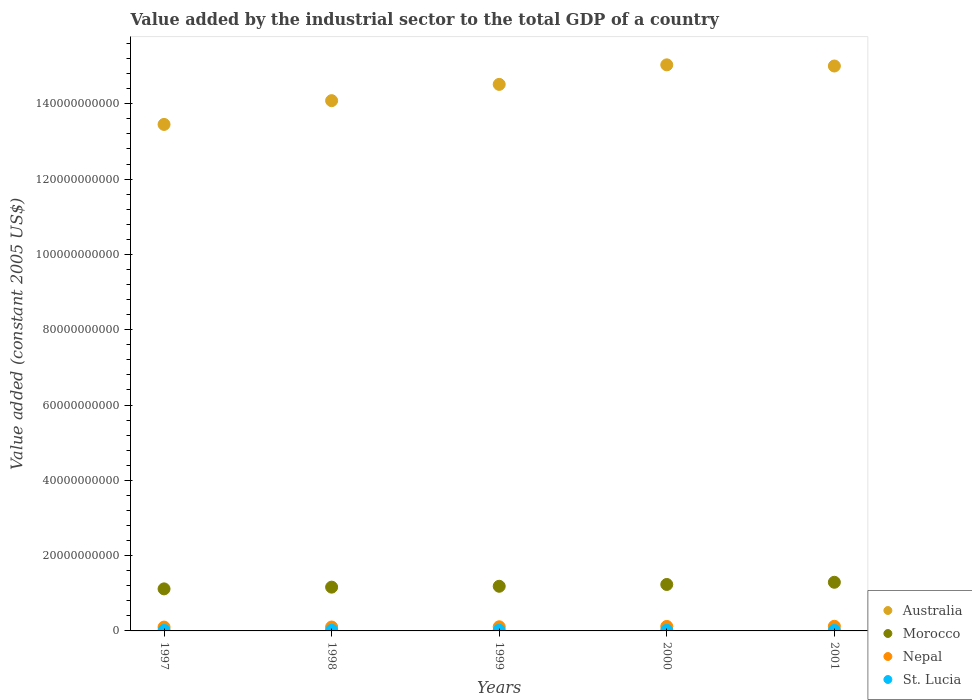How many different coloured dotlines are there?
Your answer should be compact. 4. Is the number of dotlines equal to the number of legend labels?
Your response must be concise. Yes. What is the value added by the industrial sector in St. Lucia in 2000?
Provide a succinct answer. 1.57e+08. Across all years, what is the maximum value added by the industrial sector in Australia?
Your response must be concise. 1.50e+11. Across all years, what is the minimum value added by the industrial sector in Morocco?
Give a very brief answer. 1.12e+1. What is the total value added by the industrial sector in St. Lucia in the graph?
Ensure brevity in your answer.  7.94e+08. What is the difference between the value added by the industrial sector in St. Lucia in 1997 and that in 2001?
Give a very brief answer. 7.04e+06. What is the difference between the value added by the industrial sector in St. Lucia in 1997 and the value added by the industrial sector in Nepal in 2000?
Your answer should be compact. -1.04e+09. What is the average value added by the industrial sector in Morocco per year?
Your answer should be compact. 1.20e+1. In the year 1998, what is the difference between the value added by the industrial sector in Morocco and value added by the industrial sector in Australia?
Offer a terse response. -1.29e+11. In how many years, is the value added by the industrial sector in Morocco greater than 76000000000 US$?
Offer a terse response. 0. What is the ratio of the value added by the industrial sector in Morocco in 2000 to that in 2001?
Offer a terse response. 0.95. What is the difference between the highest and the second highest value added by the industrial sector in Morocco?
Your response must be concise. 5.85e+08. What is the difference between the highest and the lowest value added by the industrial sector in Morocco?
Provide a succinct answer. 1.75e+09. Is the sum of the value added by the industrial sector in Morocco in 1999 and 2000 greater than the maximum value added by the industrial sector in St. Lucia across all years?
Give a very brief answer. Yes. Is it the case that in every year, the sum of the value added by the industrial sector in Australia and value added by the industrial sector in Nepal  is greater than the value added by the industrial sector in Morocco?
Give a very brief answer. Yes. Does the value added by the industrial sector in St. Lucia monotonically increase over the years?
Provide a short and direct response. No. Is the value added by the industrial sector in Nepal strictly greater than the value added by the industrial sector in Australia over the years?
Provide a short and direct response. No. Is the value added by the industrial sector in Morocco strictly less than the value added by the industrial sector in Australia over the years?
Ensure brevity in your answer.  Yes. How many dotlines are there?
Your response must be concise. 4. How many years are there in the graph?
Your response must be concise. 5. Are the values on the major ticks of Y-axis written in scientific E-notation?
Ensure brevity in your answer.  No. Does the graph contain any zero values?
Provide a short and direct response. No. Does the graph contain grids?
Provide a succinct answer. No. How many legend labels are there?
Your answer should be very brief. 4. How are the legend labels stacked?
Offer a very short reply. Vertical. What is the title of the graph?
Offer a terse response. Value added by the industrial sector to the total GDP of a country. Does "Middle income" appear as one of the legend labels in the graph?
Provide a succinct answer. No. What is the label or title of the X-axis?
Your answer should be compact. Years. What is the label or title of the Y-axis?
Offer a very short reply. Value added (constant 2005 US$). What is the Value added (constant 2005 US$) in Australia in 1997?
Provide a succinct answer. 1.35e+11. What is the Value added (constant 2005 US$) of Morocco in 1997?
Provide a short and direct response. 1.12e+1. What is the Value added (constant 2005 US$) of Nepal in 1997?
Give a very brief answer. 1.01e+09. What is the Value added (constant 2005 US$) of St. Lucia in 1997?
Keep it short and to the point. 1.49e+08. What is the Value added (constant 2005 US$) of Australia in 1998?
Your response must be concise. 1.41e+11. What is the Value added (constant 2005 US$) in Morocco in 1998?
Offer a terse response. 1.16e+1. What is the Value added (constant 2005 US$) of Nepal in 1998?
Ensure brevity in your answer.  1.04e+09. What is the Value added (constant 2005 US$) in St. Lucia in 1998?
Offer a very short reply. 1.66e+08. What is the Value added (constant 2005 US$) in Australia in 1999?
Offer a terse response. 1.45e+11. What is the Value added (constant 2005 US$) in Morocco in 1999?
Offer a terse response. 1.19e+1. What is the Value added (constant 2005 US$) in Nepal in 1999?
Your response must be concise. 1.10e+09. What is the Value added (constant 2005 US$) in St. Lucia in 1999?
Keep it short and to the point. 1.80e+08. What is the Value added (constant 2005 US$) of Australia in 2000?
Your answer should be compact. 1.50e+11. What is the Value added (constant 2005 US$) of Morocco in 2000?
Give a very brief answer. 1.23e+1. What is the Value added (constant 2005 US$) of Nepal in 2000?
Make the answer very short. 1.19e+09. What is the Value added (constant 2005 US$) of St. Lucia in 2000?
Your response must be concise. 1.57e+08. What is the Value added (constant 2005 US$) of Australia in 2001?
Your response must be concise. 1.50e+11. What is the Value added (constant 2005 US$) in Morocco in 2001?
Make the answer very short. 1.29e+1. What is the Value added (constant 2005 US$) of Nepal in 2001?
Offer a terse response. 1.23e+09. What is the Value added (constant 2005 US$) in St. Lucia in 2001?
Your answer should be very brief. 1.42e+08. Across all years, what is the maximum Value added (constant 2005 US$) of Australia?
Your answer should be very brief. 1.50e+11. Across all years, what is the maximum Value added (constant 2005 US$) in Morocco?
Offer a very short reply. 1.29e+1. Across all years, what is the maximum Value added (constant 2005 US$) of Nepal?
Your answer should be very brief. 1.23e+09. Across all years, what is the maximum Value added (constant 2005 US$) in St. Lucia?
Ensure brevity in your answer.  1.80e+08. Across all years, what is the minimum Value added (constant 2005 US$) of Australia?
Make the answer very short. 1.35e+11. Across all years, what is the minimum Value added (constant 2005 US$) in Morocco?
Offer a terse response. 1.12e+1. Across all years, what is the minimum Value added (constant 2005 US$) in Nepal?
Offer a very short reply. 1.01e+09. Across all years, what is the minimum Value added (constant 2005 US$) of St. Lucia?
Offer a terse response. 1.42e+08. What is the total Value added (constant 2005 US$) of Australia in the graph?
Offer a terse response. 7.21e+11. What is the total Value added (constant 2005 US$) of Morocco in the graph?
Give a very brief answer. 5.99e+1. What is the total Value added (constant 2005 US$) of Nepal in the graph?
Your answer should be compact. 5.57e+09. What is the total Value added (constant 2005 US$) in St. Lucia in the graph?
Give a very brief answer. 7.94e+08. What is the difference between the Value added (constant 2005 US$) in Australia in 1997 and that in 1998?
Ensure brevity in your answer.  -6.31e+09. What is the difference between the Value added (constant 2005 US$) in Morocco in 1997 and that in 1998?
Offer a very short reply. -4.59e+08. What is the difference between the Value added (constant 2005 US$) in Nepal in 1997 and that in 1998?
Your answer should be very brief. -2.34e+07. What is the difference between the Value added (constant 2005 US$) in St. Lucia in 1997 and that in 1998?
Give a very brief answer. -1.72e+07. What is the difference between the Value added (constant 2005 US$) of Australia in 1997 and that in 1999?
Ensure brevity in your answer.  -1.06e+1. What is the difference between the Value added (constant 2005 US$) in Morocco in 1997 and that in 1999?
Give a very brief answer. -6.90e+08. What is the difference between the Value added (constant 2005 US$) of Nepal in 1997 and that in 1999?
Provide a succinct answer. -8.55e+07. What is the difference between the Value added (constant 2005 US$) in St. Lucia in 1997 and that in 1999?
Give a very brief answer. -3.13e+07. What is the difference between the Value added (constant 2005 US$) of Australia in 1997 and that in 2000?
Your answer should be very brief. -1.58e+1. What is the difference between the Value added (constant 2005 US$) of Morocco in 1997 and that in 2000?
Keep it short and to the point. -1.17e+09. What is the difference between the Value added (constant 2005 US$) of Nepal in 1997 and that in 2000?
Make the answer very short. -1.76e+08. What is the difference between the Value added (constant 2005 US$) in St. Lucia in 1997 and that in 2000?
Offer a terse response. -8.48e+06. What is the difference between the Value added (constant 2005 US$) of Australia in 1997 and that in 2001?
Make the answer very short. -1.55e+1. What is the difference between the Value added (constant 2005 US$) of Morocco in 1997 and that in 2001?
Ensure brevity in your answer.  -1.75e+09. What is the difference between the Value added (constant 2005 US$) in Nepal in 1997 and that in 2001?
Your answer should be very brief. -2.19e+08. What is the difference between the Value added (constant 2005 US$) of St. Lucia in 1997 and that in 2001?
Provide a succinct answer. 7.04e+06. What is the difference between the Value added (constant 2005 US$) of Australia in 1998 and that in 1999?
Offer a very short reply. -4.32e+09. What is the difference between the Value added (constant 2005 US$) in Morocco in 1998 and that in 1999?
Ensure brevity in your answer.  -2.32e+08. What is the difference between the Value added (constant 2005 US$) in Nepal in 1998 and that in 1999?
Provide a succinct answer. -6.21e+07. What is the difference between the Value added (constant 2005 US$) in St. Lucia in 1998 and that in 1999?
Your answer should be very brief. -1.40e+07. What is the difference between the Value added (constant 2005 US$) in Australia in 1998 and that in 2000?
Give a very brief answer. -9.51e+09. What is the difference between the Value added (constant 2005 US$) of Morocco in 1998 and that in 2000?
Ensure brevity in your answer.  -7.09e+08. What is the difference between the Value added (constant 2005 US$) of Nepal in 1998 and that in 2000?
Your answer should be very brief. -1.52e+08. What is the difference between the Value added (constant 2005 US$) of St. Lucia in 1998 and that in 2000?
Offer a terse response. 8.74e+06. What is the difference between the Value added (constant 2005 US$) in Australia in 1998 and that in 2001?
Make the answer very short. -9.20e+09. What is the difference between the Value added (constant 2005 US$) in Morocco in 1998 and that in 2001?
Keep it short and to the point. -1.29e+09. What is the difference between the Value added (constant 2005 US$) of Nepal in 1998 and that in 2001?
Provide a succinct answer. -1.95e+08. What is the difference between the Value added (constant 2005 US$) in St. Lucia in 1998 and that in 2001?
Offer a very short reply. 2.43e+07. What is the difference between the Value added (constant 2005 US$) in Australia in 1999 and that in 2000?
Provide a short and direct response. -5.19e+09. What is the difference between the Value added (constant 2005 US$) in Morocco in 1999 and that in 2000?
Offer a terse response. -4.78e+08. What is the difference between the Value added (constant 2005 US$) in Nepal in 1999 and that in 2000?
Your answer should be compact. -9.02e+07. What is the difference between the Value added (constant 2005 US$) of St. Lucia in 1999 and that in 2000?
Give a very brief answer. 2.28e+07. What is the difference between the Value added (constant 2005 US$) in Australia in 1999 and that in 2001?
Keep it short and to the point. -4.88e+09. What is the difference between the Value added (constant 2005 US$) of Morocco in 1999 and that in 2001?
Your response must be concise. -1.06e+09. What is the difference between the Value added (constant 2005 US$) of Nepal in 1999 and that in 2001?
Provide a short and direct response. -1.33e+08. What is the difference between the Value added (constant 2005 US$) in St. Lucia in 1999 and that in 2001?
Ensure brevity in your answer.  3.83e+07. What is the difference between the Value added (constant 2005 US$) of Australia in 2000 and that in 2001?
Offer a very short reply. 3.08e+08. What is the difference between the Value added (constant 2005 US$) in Morocco in 2000 and that in 2001?
Give a very brief answer. -5.85e+08. What is the difference between the Value added (constant 2005 US$) of Nepal in 2000 and that in 2001?
Keep it short and to the point. -4.28e+07. What is the difference between the Value added (constant 2005 US$) in St. Lucia in 2000 and that in 2001?
Offer a very short reply. 1.55e+07. What is the difference between the Value added (constant 2005 US$) in Australia in 1997 and the Value added (constant 2005 US$) in Morocco in 1998?
Keep it short and to the point. 1.23e+11. What is the difference between the Value added (constant 2005 US$) in Australia in 1997 and the Value added (constant 2005 US$) in Nepal in 1998?
Provide a succinct answer. 1.33e+11. What is the difference between the Value added (constant 2005 US$) in Australia in 1997 and the Value added (constant 2005 US$) in St. Lucia in 1998?
Provide a short and direct response. 1.34e+11. What is the difference between the Value added (constant 2005 US$) of Morocco in 1997 and the Value added (constant 2005 US$) of Nepal in 1998?
Keep it short and to the point. 1.01e+1. What is the difference between the Value added (constant 2005 US$) in Morocco in 1997 and the Value added (constant 2005 US$) in St. Lucia in 1998?
Make the answer very short. 1.10e+1. What is the difference between the Value added (constant 2005 US$) of Nepal in 1997 and the Value added (constant 2005 US$) of St. Lucia in 1998?
Your response must be concise. 8.48e+08. What is the difference between the Value added (constant 2005 US$) in Australia in 1997 and the Value added (constant 2005 US$) in Morocco in 1999?
Make the answer very short. 1.23e+11. What is the difference between the Value added (constant 2005 US$) in Australia in 1997 and the Value added (constant 2005 US$) in Nepal in 1999?
Your response must be concise. 1.33e+11. What is the difference between the Value added (constant 2005 US$) of Australia in 1997 and the Value added (constant 2005 US$) of St. Lucia in 1999?
Your answer should be very brief. 1.34e+11. What is the difference between the Value added (constant 2005 US$) of Morocco in 1997 and the Value added (constant 2005 US$) of Nepal in 1999?
Ensure brevity in your answer.  1.01e+1. What is the difference between the Value added (constant 2005 US$) in Morocco in 1997 and the Value added (constant 2005 US$) in St. Lucia in 1999?
Give a very brief answer. 1.10e+1. What is the difference between the Value added (constant 2005 US$) in Nepal in 1997 and the Value added (constant 2005 US$) in St. Lucia in 1999?
Your response must be concise. 8.34e+08. What is the difference between the Value added (constant 2005 US$) in Australia in 1997 and the Value added (constant 2005 US$) in Morocco in 2000?
Your answer should be compact. 1.22e+11. What is the difference between the Value added (constant 2005 US$) in Australia in 1997 and the Value added (constant 2005 US$) in Nepal in 2000?
Your response must be concise. 1.33e+11. What is the difference between the Value added (constant 2005 US$) in Australia in 1997 and the Value added (constant 2005 US$) in St. Lucia in 2000?
Offer a very short reply. 1.34e+11. What is the difference between the Value added (constant 2005 US$) in Morocco in 1997 and the Value added (constant 2005 US$) in Nepal in 2000?
Your answer should be compact. 9.98e+09. What is the difference between the Value added (constant 2005 US$) of Morocco in 1997 and the Value added (constant 2005 US$) of St. Lucia in 2000?
Keep it short and to the point. 1.10e+1. What is the difference between the Value added (constant 2005 US$) of Nepal in 1997 and the Value added (constant 2005 US$) of St. Lucia in 2000?
Your answer should be compact. 8.56e+08. What is the difference between the Value added (constant 2005 US$) of Australia in 1997 and the Value added (constant 2005 US$) of Morocco in 2001?
Your answer should be compact. 1.22e+11. What is the difference between the Value added (constant 2005 US$) in Australia in 1997 and the Value added (constant 2005 US$) in Nepal in 2001?
Provide a succinct answer. 1.33e+11. What is the difference between the Value added (constant 2005 US$) in Australia in 1997 and the Value added (constant 2005 US$) in St. Lucia in 2001?
Make the answer very short. 1.34e+11. What is the difference between the Value added (constant 2005 US$) of Morocco in 1997 and the Value added (constant 2005 US$) of Nepal in 2001?
Give a very brief answer. 9.93e+09. What is the difference between the Value added (constant 2005 US$) in Morocco in 1997 and the Value added (constant 2005 US$) in St. Lucia in 2001?
Your answer should be compact. 1.10e+1. What is the difference between the Value added (constant 2005 US$) of Nepal in 1997 and the Value added (constant 2005 US$) of St. Lucia in 2001?
Make the answer very short. 8.72e+08. What is the difference between the Value added (constant 2005 US$) of Australia in 1998 and the Value added (constant 2005 US$) of Morocco in 1999?
Offer a very short reply. 1.29e+11. What is the difference between the Value added (constant 2005 US$) of Australia in 1998 and the Value added (constant 2005 US$) of Nepal in 1999?
Offer a very short reply. 1.40e+11. What is the difference between the Value added (constant 2005 US$) in Australia in 1998 and the Value added (constant 2005 US$) in St. Lucia in 1999?
Ensure brevity in your answer.  1.41e+11. What is the difference between the Value added (constant 2005 US$) in Morocco in 1998 and the Value added (constant 2005 US$) in Nepal in 1999?
Ensure brevity in your answer.  1.05e+1. What is the difference between the Value added (constant 2005 US$) in Morocco in 1998 and the Value added (constant 2005 US$) in St. Lucia in 1999?
Offer a terse response. 1.14e+1. What is the difference between the Value added (constant 2005 US$) of Nepal in 1998 and the Value added (constant 2005 US$) of St. Lucia in 1999?
Your answer should be very brief. 8.57e+08. What is the difference between the Value added (constant 2005 US$) of Australia in 1998 and the Value added (constant 2005 US$) of Morocco in 2000?
Offer a very short reply. 1.28e+11. What is the difference between the Value added (constant 2005 US$) of Australia in 1998 and the Value added (constant 2005 US$) of Nepal in 2000?
Offer a terse response. 1.40e+11. What is the difference between the Value added (constant 2005 US$) in Australia in 1998 and the Value added (constant 2005 US$) in St. Lucia in 2000?
Ensure brevity in your answer.  1.41e+11. What is the difference between the Value added (constant 2005 US$) in Morocco in 1998 and the Value added (constant 2005 US$) in Nepal in 2000?
Your response must be concise. 1.04e+1. What is the difference between the Value added (constant 2005 US$) in Morocco in 1998 and the Value added (constant 2005 US$) in St. Lucia in 2000?
Provide a short and direct response. 1.15e+1. What is the difference between the Value added (constant 2005 US$) of Nepal in 1998 and the Value added (constant 2005 US$) of St. Lucia in 2000?
Make the answer very short. 8.80e+08. What is the difference between the Value added (constant 2005 US$) in Australia in 1998 and the Value added (constant 2005 US$) in Morocco in 2001?
Your response must be concise. 1.28e+11. What is the difference between the Value added (constant 2005 US$) of Australia in 1998 and the Value added (constant 2005 US$) of Nepal in 2001?
Keep it short and to the point. 1.40e+11. What is the difference between the Value added (constant 2005 US$) in Australia in 1998 and the Value added (constant 2005 US$) in St. Lucia in 2001?
Offer a very short reply. 1.41e+11. What is the difference between the Value added (constant 2005 US$) in Morocco in 1998 and the Value added (constant 2005 US$) in Nepal in 2001?
Give a very brief answer. 1.04e+1. What is the difference between the Value added (constant 2005 US$) in Morocco in 1998 and the Value added (constant 2005 US$) in St. Lucia in 2001?
Make the answer very short. 1.15e+1. What is the difference between the Value added (constant 2005 US$) of Nepal in 1998 and the Value added (constant 2005 US$) of St. Lucia in 2001?
Offer a very short reply. 8.95e+08. What is the difference between the Value added (constant 2005 US$) in Australia in 1999 and the Value added (constant 2005 US$) in Morocco in 2000?
Offer a terse response. 1.33e+11. What is the difference between the Value added (constant 2005 US$) in Australia in 1999 and the Value added (constant 2005 US$) in Nepal in 2000?
Your answer should be very brief. 1.44e+11. What is the difference between the Value added (constant 2005 US$) in Australia in 1999 and the Value added (constant 2005 US$) in St. Lucia in 2000?
Keep it short and to the point. 1.45e+11. What is the difference between the Value added (constant 2005 US$) of Morocco in 1999 and the Value added (constant 2005 US$) of Nepal in 2000?
Your response must be concise. 1.07e+1. What is the difference between the Value added (constant 2005 US$) of Morocco in 1999 and the Value added (constant 2005 US$) of St. Lucia in 2000?
Your answer should be compact. 1.17e+1. What is the difference between the Value added (constant 2005 US$) of Nepal in 1999 and the Value added (constant 2005 US$) of St. Lucia in 2000?
Ensure brevity in your answer.  9.42e+08. What is the difference between the Value added (constant 2005 US$) in Australia in 1999 and the Value added (constant 2005 US$) in Morocco in 2001?
Offer a very short reply. 1.32e+11. What is the difference between the Value added (constant 2005 US$) in Australia in 1999 and the Value added (constant 2005 US$) in Nepal in 2001?
Make the answer very short. 1.44e+11. What is the difference between the Value added (constant 2005 US$) in Australia in 1999 and the Value added (constant 2005 US$) in St. Lucia in 2001?
Offer a very short reply. 1.45e+11. What is the difference between the Value added (constant 2005 US$) of Morocco in 1999 and the Value added (constant 2005 US$) of Nepal in 2001?
Keep it short and to the point. 1.06e+1. What is the difference between the Value added (constant 2005 US$) of Morocco in 1999 and the Value added (constant 2005 US$) of St. Lucia in 2001?
Provide a succinct answer. 1.17e+1. What is the difference between the Value added (constant 2005 US$) in Nepal in 1999 and the Value added (constant 2005 US$) in St. Lucia in 2001?
Make the answer very short. 9.57e+08. What is the difference between the Value added (constant 2005 US$) of Australia in 2000 and the Value added (constant 2005 US$) of Morocco in 2001?
Provide a succinct answer. 1.37e+11. What is the difference between the Value added (constant 2005 US$) of Australia in 2000 and the Value added (constant 2005 US$) of Nepal in 2001?
Ensure brevity in your answer.  1.49e+11. What is the difference between the Value added (constant 2005 US$) in Australia in 2000 and the Value added (constant 2005 US$) in St. Lucia in 2001?
Make the answer very short. 1.50e+11. What is the difference between the Value added (constant 2005 US$) in Morocco in 2000 and the Value added (constant 2005 US$) in Nepal in 2001?
Keep it short and to the point. 1.11e+1. What is the difference between the Value added (constant 2005 US$) in Morocco in 2000 and the Value added (constant 2005 US$) in St. Lucia in 2001?
Offer a terse response. 1.22e+1. What is the difference between the Value added (constant 2005 US$) of Nepal in 2000 and the Value added (constant 2005 US$) of St. Lucia in 2001?
Ensure brevity in your answer.  1.05e+09. What is the average Value added (constant 2005 US$) in Australia per year?
Ensure brevity in your answer.  1.44e+11. What is the average Value added (constant 2005 US$) of Morocco per year?
Provide a succinct answer. 1.20e+1. What is the average Value added (constant 2005 US$) in Nepal per year?
Your answer should be compact. 1.11e+09. What is the average Value added (constant 2005 US$) in St. Lucia per year?
Provide a short and direct response. 1.59e+08. In the year 1997, what is the difference between the Value added (constant 2005 US$) of Australia and Value added (constant 2005 US$) of Morocco?
Make the answer very short. 1.23e+11. In the year 1997, what is the difference between the Value added (constant 2005 US$) of Australia and Value added (constant 2005 US$) of Nepal?
Offer a terse response. 1.34e+11. In the year 1997, what is the difference between the Value added (constant 2005 US$) of Australia and Value added (constant 2005 US$) of St. Lucia?
Your answer should be very brief. 1.34e+11. In the year 1997, what is the difference between the Value added (constant 2005 US$) in Morocco and Value added (constant 2005 US$) in Nepal?
Your answer should be compact. 1.02e+1. In the year 1997, what is the difference between the Value added (constant 2005 US$) in Morocco and Value added (constant 2005 US$) in St. Lucia?
Keep it short and to the point. 1.10e+1. In the year 1997, what is the difference between the Value added (constant 2005 US$) of Nepal and Value added (constant 2005 US$) of St. Lucia?
Provide a short and direct response. 8.65e+08. In the year 1998, what is the difference between the Value added (constant 2005 US$) in Australia and Value added (constant 2005 US$) in Morocco?
Your answer should be very brief. 1.29e+11. In the year 1998, what is the difference between the Value added (constant 2005 US$) in Australia and Value added (constant 2005 US$) in Nepal?
Your response must be concise. 1.40e+11. In the year 1998, what is the difference between the Value added (constant 2005 US$) in Australia and Value added (constant 2005 US$) in St. Lucia?
Keep it short and to the point. 1.41e+11. In the year 1998, what is the difference between the Value added (constant 2005 US$) in Morocco and Value added (constant 2005 US$) in Nepal?
Ensure brevity in your answer.  1.06e+1. In the year 1998, what is the difference between the Value added (constant 2005 US$) of Morocco and Value added (constant 2005 US$) of St. Lucia?
Offer a very short reply. 1.15e+1. In the year 1998, what is the difference between the Value added (constant 2005 US$) of Nepal and Value added (constant 2005 US$) of St. Lucia?
Your answer should be very brief. 8.71e+08. In the year 1999, what is the difference between the Value added (constant 2005 US$) in Australia and Value added (constant 2005 US$) in Morocco?
Your answer should be very brief. 1.33e+11. In the year 1999, what is the difference between the Value added (constant 2005 US$) in Australia and Value added (constant 2005 US$) in Nepal?
Give a very brief answer. 1.44e+11. In the year 1999, what is the difference between the Value added (constant 2005 US$) in Australia and Value added (constant 2005 US$) in St. Lucia?
Your response must be concise. 1.45e+11. In the year 1999, what is the difference between the Value added (constant 2005 US$) of Morocco and Value added (constant 2005 US$) of Nepal?
Make the answer very short. 1.08e+1. In the year 1999, what is the difference between the Value added (constant 2005 US$) in Morocco and Value added (constant 2005 US$) in St. Lucia?
Offer a terse response. 1.17e+1. In the year 1999, what is the difference between the Value added (constant 2005 US$) in Nepal and Value added (constant 2005 US$) in St. Lucia?
Make the answer very short. 9.19e+08. In the year 2000, what is the difference between the Value added (constant 2005 US$) in Australia and Value added (constant 2005 US$) in Morocco?
Offer a very short reply. 1.38e+11. In the year 2000, what is the difference between the Value added (constant 2005 US$) of Australia and Value added (constant 2005 US$) of Nepal?
Offer a terse response. 1.49e+11. In the year 2000, what is the difference between the Value added (constant 2005 US$) in Australia and Value added (constant 2005 US$) in St. Lucia?
Keep it short and to the point. 1.50e+11. In the year 2000, what is the difference between the Value added (constant 2005 US$) in Morocco and Value added (constant 2005 US$) in Nepal?
Provide a succinct answer. 1.11e+1. In the year 2000, what is the difference between the Value added (constant 2005 US$) of Morocco and Value added (constant 2005 US$) of St. Lucia?
Make the answer very short. 1.22e+1. In the year 2000, what is the difference between the Value added (constant 2005 US$) of Nepal and Value added (constant 2005 US$) of St. Lucia?
Give a very brief answer. 1.03e+09. In the year 2001, what is the difference between the Value added (constant 2005 US$) of Australia and Value added (constant 2005 US$) of Morocco?
Provide a succinct answer. 1.37e+11. In the year 2001, what is the difference between the Value added (constant 2005 US$) of Australia and Value added (constant 2005 US$) of Nepal?
Make the answer very short. 1.49e+11. In the year 2001, what is the difference between the Value added (constant 2005 US$) in Australia and Value added (constant 2005 US$) in St. Lucia?
Provide a short and direct response. 1.50e+11. In the year 2001, what is the difference between the Value added (constant 2005 US$) in Morocco and Value added (constant 2005 US$) in Nepal?
Offer a very short reply. 1.17e+1. In the year 2001, what is the difference between the Value added (constant 2005 US$) of Morocco and Value added (constant 2005 US$) of St. Lucia?
Provide a succinct answer. 1.28e+1. In the year 2001, what is the difference between the Value added (constant 2005 US$) in Nepal and Value added (constant 2005 US$) in St. Lucia?
Provide a short and direct response. 1.09e+09. What is the ratio of the Value added (constant 2005 US$) of Australia in 1997 to that in 1998?
Keep it short and to the point. 0.96. What is the ratio of the Value added (constant 2005 US$) of Morocco in 1997 to that in 1998?
Make the answer very short. 0.96. What is the ratio of the Value added (constant 2005 US$) in Nepal in 1997 to that in 1998?
Your answer should be very brief. 0.98. What is the ratio of the Value added (constant 2005 US$) of St. Lucia in 1997 to that in 1998?
Provide a succinct answer. 0.9. What is the ratio of the Value added (constant 2005 US$) of Australia in 1997 to that in 1999?
Offer a terse response. 0.93. What is the ratio of the Value added (constant 2005 US$) in Morocco in 1997 to that in 1999?
Your answer should be very brief. 0.94. What is the ratio of the Value added (constant 2005 US$) of Nepal in 1997 to that in 1999?
Give a very brief answer. 0.92. What is the ratio of the Value added (constant 2005 US$) of St. Lucia in 1997 to that in 1999?
Keep it short and to the point. 0.83. What is the ratio of the Value added (constant 2005 US$) of Australia in 1997 to that in 2000?
Provide a short and direct response. 0.89. What is the ratio of the Value added (constant 2005 US$) in Morocco in 1997 to that in 2000?
Keep it short and to the point. 0.91. What is the ratio of the Value added (constant 2005 US$) in Nepal in 1997 to that in 2000?
Offer a terse response. 0.85. What is the ratio of the Value added (constant 2005 US$) in St. Lucia in 1997 to that in 2000?
Your response must be concise. 0.95. What is the ratio of the Value added (constant 2005 US$) of Australia in 1997 to that in 2001?
Provide a succinct answer. 0.9. What is the ratio of the Value added (constant 2005 US$) of Morocco in 1997 to that in 2001?
Keep it short and to the point. 0.86. What is the ratio of the Value added (constant 2005 US$) in Nepal in 1997 to that in 2001?
Your answer should be compact. 0.82. What is the ratio of the Value added (constant 2005 US$) of St. Lucia in 1997 to that in 2001?
Offer a very short reply. 1.05. What is the ratio of the Value added (constant 2005 US$) of Australia in 1998 to that in 1999?
Your answer should be very brief. 0.97. What is the ratio of the Value added (constant 2005 US$) of Morocco in 1998 to that in 1999?
Give a very brief answer. 0.98. What is the ratio of the Value added (constant 2005 US$) of Nepal in 1998 to that in 1999?
Make the answer very short. 0.94. What is the ratio of the Value added (constant 2005 US$) in St. Lucia in 1998 to that in 1999?
Provide a succinct answer. 0.92. What is the ratio of the Value added (constant 2005 US$) of Australia in 1998 to that in 2000?
Provide a succinct answer. 0.94. What is the ratio of the Value added (constant 2005 US$) in Morocco in 1998 to that in 2000?
Provide a succinct answer. 0.94. What is the ratio of the Value added (constant 2005 US$) in Nepal in 1998 to that in 2000?
Provide a short and direct response. 0.87. What is the ratio of the Value added (constant 2005 US$) of St. Lucia in 1998 to that in 2000?
Keep it short and to the point. 1.06. What is the ratio of the Value added (constant 2005 US$) of Australia in 1998 to that in 2001?
Your answer should be compact. 0.94. What is the ratio of the Value added (constant 2005 US$) of Morocco in 1998 to that in 2001?
Your answer should be compact. 0.9. What is the ratio of the Value added (constant 2005 US$) of Nepal in 1998 to that in 2001?
Offer a terse response. 0.84. What is the ratio of the Value added (constant 2005 US$) in St. Lucia in 1998 to that in 2001?
Keep it short and to the point. 1.17. What is the ratio of the Value added (constant 2005 US$) in Australia in 1999 to that in 2000?
Your answer should be compact. 0.97. What is the ratio of the Value added (constant 2005 US$) in Morocco in 1999 to that in 2000?
Offer a very short reply. 0.96. What is the ratio of the Value added (constant 2005 US$) in Nepal in 1999 to that in 2000?
Provide a succinct answer. 0.92. What is the ratio of the Value added (constant 2005 US$) in St. Lucia in 1999 to that in 2000?
Provide a succinct answer. 1.14. What is the ratio of the Value added (constant 2005 US$) in Australia in 1999 to that in 2001?
Offer a terse response. 0.97. What is the ratio of the Value added (constant 2005 US$) in Morocco in 1999 to that in 2001?
Your answer should be very brief. 0.92. What is the ratio of the Value added (constant 2005 US$) in Nepal in 1999 to that in 2001?
Provide a succinct answer. 0.89. What is the ratio of the Value added (constant 2005 US$) of St. Lucia in 1999 to that in 2001?
Your response must be concise. 1.27. What is the ratio of the Value added (constant 2005 US$) in Australia in 2000 to that in 2001?
Give a very brief answer. 1. What is the ratio of the Value added (constant 2005 US$) of Morocco in 2000 to that in 2001?
Give a very brief answer. 0.95. What is the ratio of the Value added (constant 2005 US$) in Nepal in 2000 to that in 2001?
Provide a succinct answer. 0.97. What is the ratio of the Value added (constant 2005 US$) in St. Lucia in 2000 to that in 2001?
Give a very brief answer. 1.11. What is the difference between the highest and the second highest Value added (constant 2005 US$) in Australia?
Make the answer very short. 3.08e+08. What is the difference between the highest and the second highest Value added (constant 2005 US$) of Morocco?
Your answer should be compact. 5.85e+08. What is the difference between the highest and the second highest Value added (constant 2005 US$) of Nepal?
Provide a succinct answer. 4.28e+07. What is the difference between the highest and the second highest Value added (constant 2005 US$) in St. Lucia?
Make the answer very short. 1.40e+07. What is the difference between the highest and the lowest Value added (constant 2005 US$) of Australia?
Your answer should be compact. 1.58e+1. What is the difference between the highest and the lowest Value added (constant 2005 US$) of Morocco?
Your answer should be very brief. 1.75e+09. What is the difference between the highest and the lowest Value added (constant 2005 US$) in Nepal?
Provide a short and direct response. 2.19e+08. What is the difference between the highest and the lowest Value added (constant 2005 US$) in St. Lucia?
Offer a very short reply. 3.83e+07. 